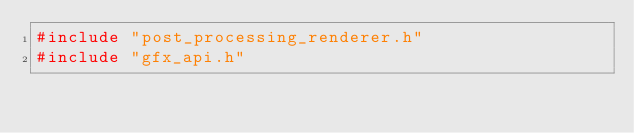Convert code to text. <code><loc_0><loc_0><loc_500><loc_500><_C++_>#include "post_processing_renderer.h"
#include "gfx_api.h"</code> 